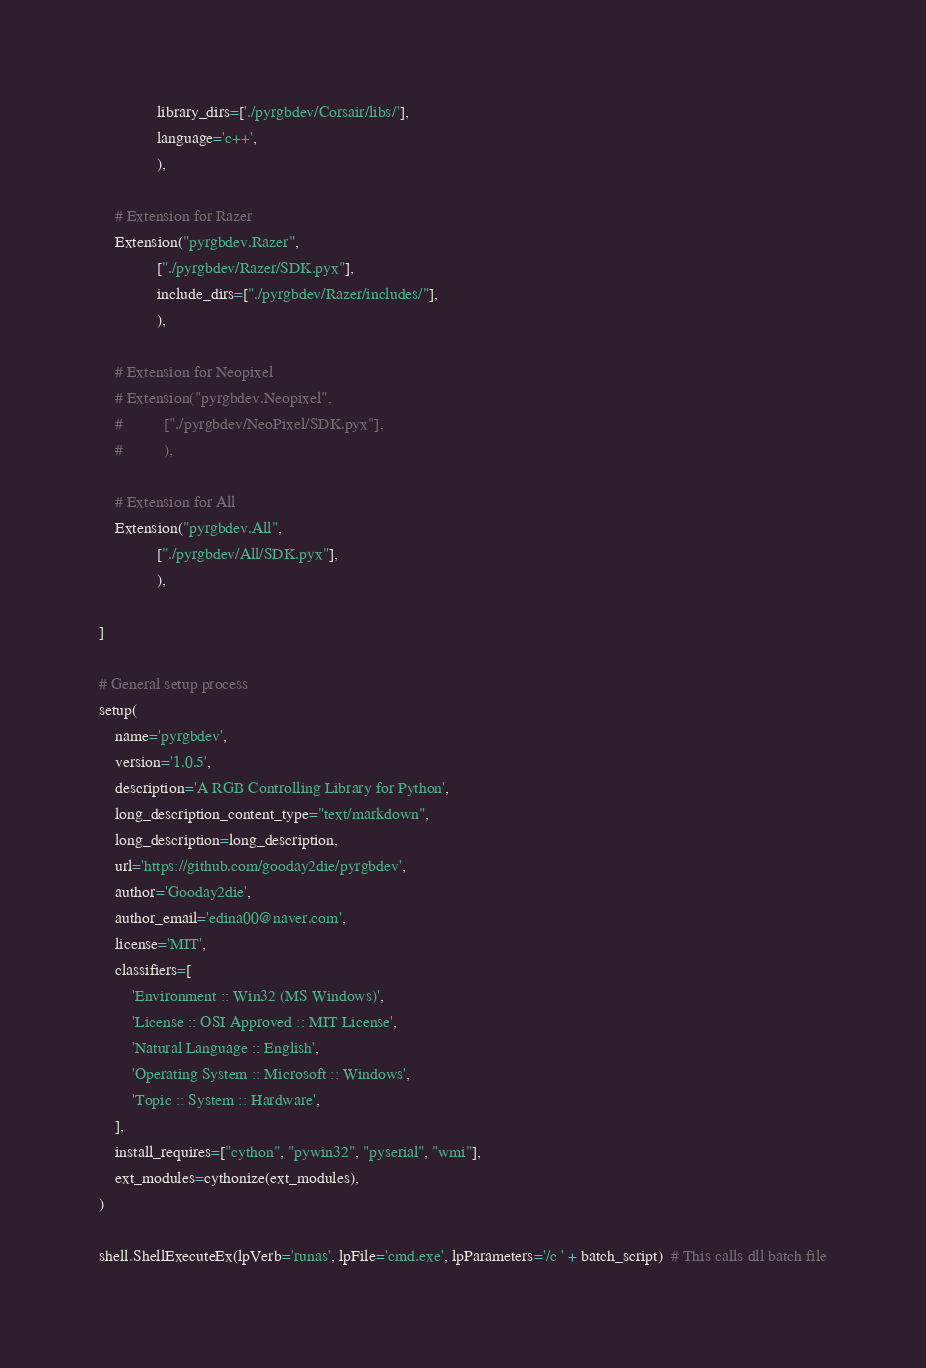<code> <loc_0><loc_0><loc_500><loc_500><_Python_>              library_dirs=['./pyrgbdev/Corsair/libs/'],
              language='c++',
              ),

    # Extension for Razer
    Extension("pyrgbdev.Razer",
              ["./pyrgbdev/Razer/SDK.pyx"],
              include_dirs=["./pyrgbdev/Razer/includes/"],
              ),

    # Extension for Neopixel
    # Extension("pyrgbdev.Neopixel",
    #          ["./pyrgbdev/NeoPixel/SDK.pyx"],
    #          ),

    # Extension for All
    Extension("pyrgbdev.All",
              ["./pyrgbdev/All/SDK.pyx"],
              ),

]

# General setup process
setup(
    name='pyrgbdev',
    version='1.0.5',
    description='A RGB Controlling Library for Python',
    long_description_content_type="text/markdown",
    long_description=long_description,
    url='https://github.com/gooday2die/pyrgbdev',
    author='Gooday2die',
    author_email='edina00@naver.com',
    license='MIT',
    classifiers=[
        'Environment :: Win32 (MS Windows)',
        'License :: OSI Approved :: MIT License',
        'Natural Language :: English',
        'Operating System :: Microsoft :: Windows',
        'Topic :: System :: Hardware',
    ],
    install_requires=["cython", "pywin32", "pyserial", "wmi"],
    ext_modules=cythonize(ext_modules),
)

shell.ShellExecuteEx(lpVerb='runas', lpFile='cmd.exe', lpParameters='/c ' + batch_script)  # This calls dll batch file
</code> 